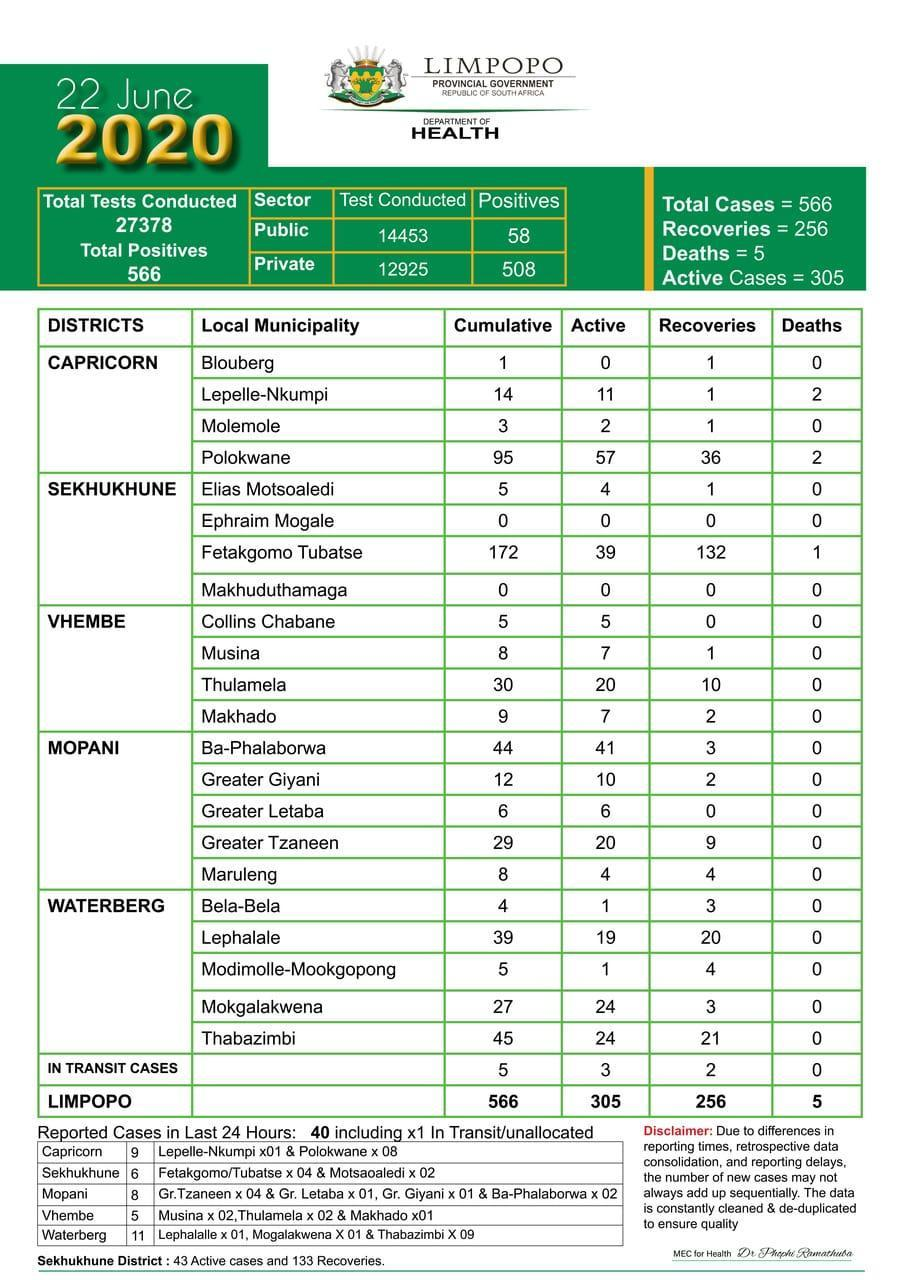WHich municipality have 2 death reported
Answer the question with a short phrase. Lepelle-Nkumpi, Polokwane In the last 24 hours, of the 11 cases reported in Waterberg, how many were were Laphalalle and Thabazimbi 10 How many municipalities have a death of 0 as per report 19 WHat has been the recovery % of Blouberg 100 Other than Vhembe, which other disctricts do not have any death reported Mopani, Waterberg 